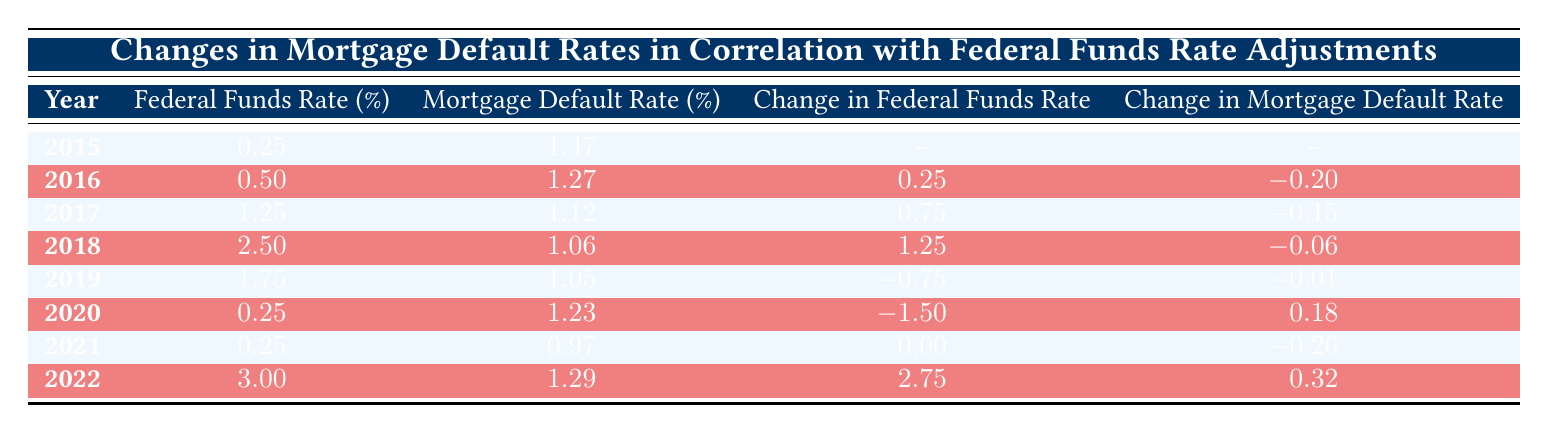What was the Federal Funds Rate in 2020? According to the table, the Federal Funds Rate for the year 2020 is 0.25%.
Answer: 0.25% What was the Mortgage Default Rate in 2018? The Mortgage Default Rate listed for the year 2018 is 1.06%.
Answer: 1.06% Did the Mortgage Default Rate improve from 2015 to 2019? To determine this, we compare the default rates: 2015 was 1.47% and 2019 was 1.05%. Since 1.05% is lower than 1.47%, it indicates an improvement.
Answer: Yes What is the change in the Federal Funds Rate from 2017 to 2018? The Federal Funds Rate in 2017 was 1.25% and in 2018 it was 2.50%. The change can be computed as 2.50% - 1.25% = 1.25%.
Answer: 1.25% What was the average Mortgage Default Rate from 2016 to 2022? We total the Mortgage Default Rates from 2016 (1.27), 2017 (1.12), 2018 (1.06), 2019 (1.05), 2020 (1.23), 2021 (0.97), and 2022 (1.29), giving a sum of 1.27 + 1.12 + 1.06 + 1.05 + 1.23 + 0.97 + 1.29 = 7.99. There are 7 values, so the average is 7.99/7 = 1.14.
Answer: 1.14 Was there any year where the Federal Funds Rate was decreased after an increase? In 2019, the Federal Funds Rate decreased from 2.50% to 1.75%, which shows a decrease following an increase from 2017 (1.25) to 2018 (2.50). Hence, this reflects a scenario where there was a decrease after an increase.
Answer: Yes How much did the Mortgage Default Rate change from 2021 to 2022? The Mortgage Default Rate in 2021 was 0.97% and in 2022 it was 1.29%. The change is thus 1.29% - 0.97% = 0.32%.
Answer: 0.32% What was the highest Federal Funds Rate in the given years? Scanning through the Federal Funds Rate percentages for each year, the highest rate is 3.00%, which was observed in the year 2022.
Answer: 3.00% In which year did both the Federal Funds Rate and the Mortgage Default Rate increase? Analyzing year by year, in 2022, the Federal Funds Rate increased significantly to 3.00% and the Mortgage Default Rate increased to 1.29% from 0.97% in 2021. Thus, both rates increased in that year.
Answer: 2022 What was the total change in the Federal Funds Rate from 2015 to 2022? From 2015 (0.25%) to 2022 (3.00%), the total change is calculated as 3.00% - 0.25% = 2.75%.
Answer: 2.75% 